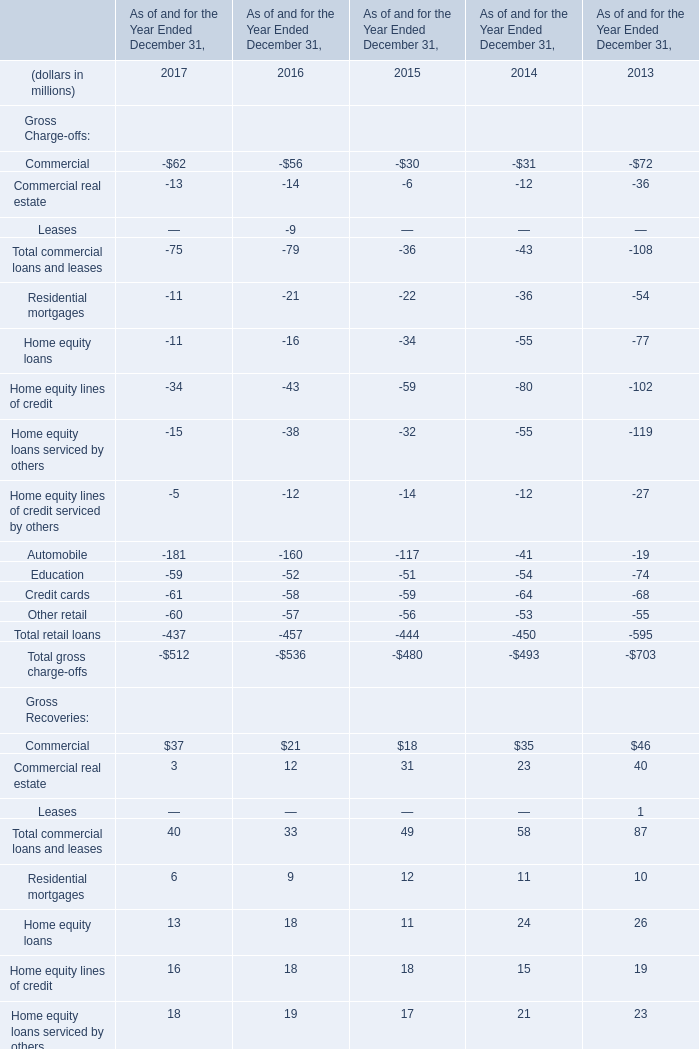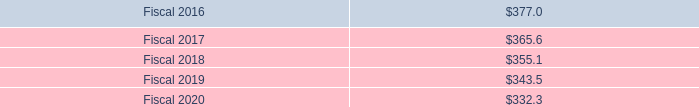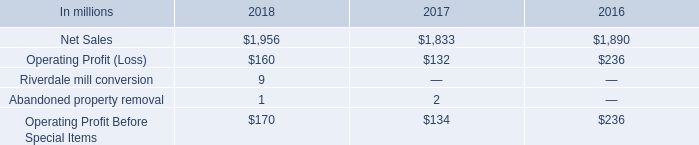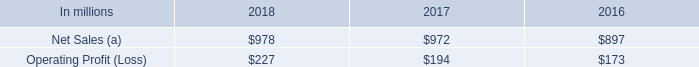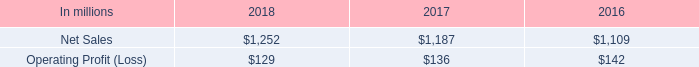What's the average of the Net Sales (a) in the years where Net Sales is positive? (in million) 
Computations: ((978 + 972) + 897)
Answer: 2847.0. 